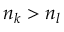<formula> <loc_0><loc_0><loc_500><loc_500>n _ { k } > n _ { l }</formula> 